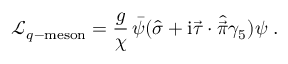<formula> <loc_0><loc_0><loc_500><loc_500>\mathcal { L } _ { q - { m e s o n } } = { \frac { g } { \chi } } \, \bar { \psi } ( \hat { \sigma } + i \vec { \tau } \cdot \hat { \vec { \pi } } \gamma _ { 5 } ) \psi \, .</formula> 